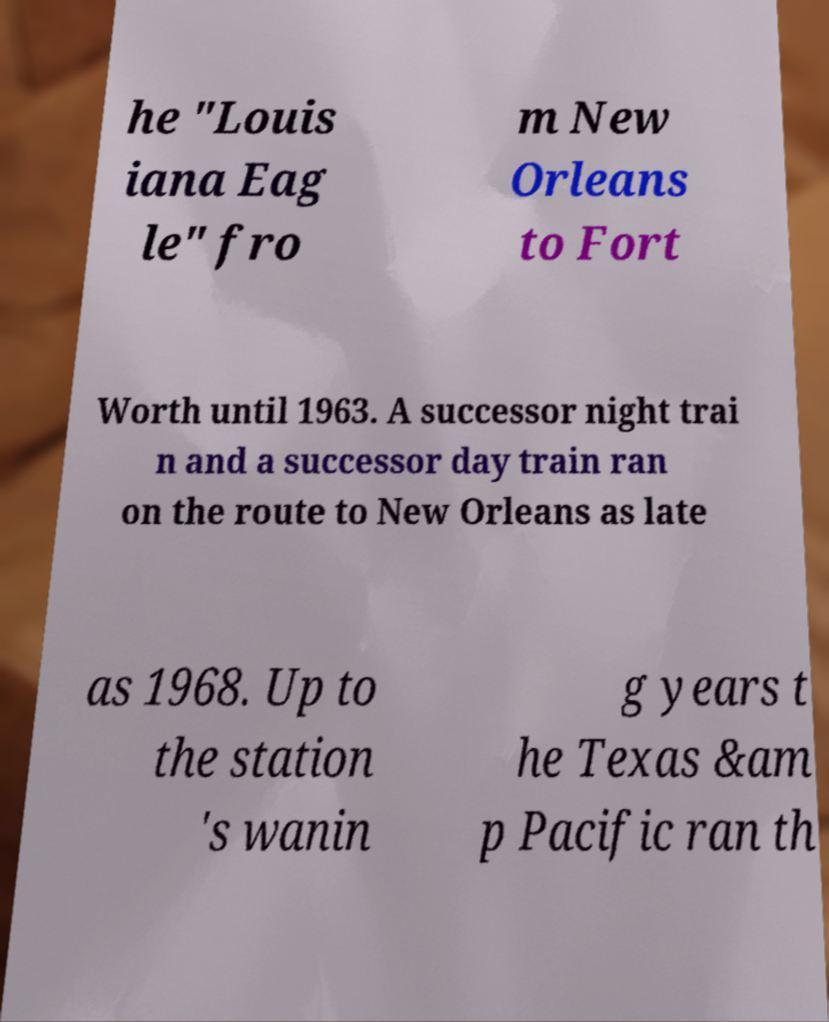Can you accurately transcribe the text from the provided image for me? he "Louis iana Eag le" fro m New Orleans to Fort Worth until 1963. A successor night trai n and a successor day train ran on the route to New Orleans as late as 1968. Up to the station 's wanin g years t he Texas &am p Pacific ran th 